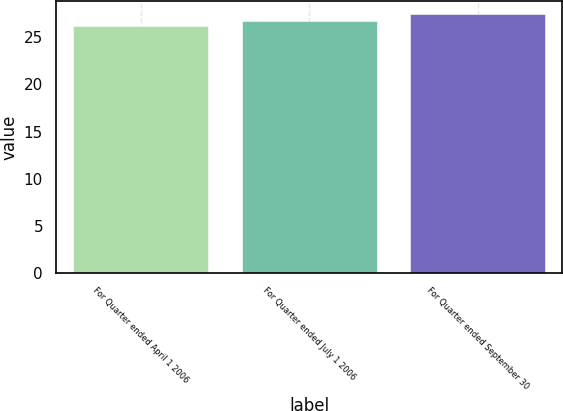Convert chart. <chart><loc_0><loc_0><loc_500><loc_500><bar_chart><fcel>For Quarter ended April 1 2006<fcel>For Quarter ended July 1 2006<fcel>For Quarter ended September 30<nl><fcel>26.2<fcel>26.73<fcel>27.46<nl></chart> 